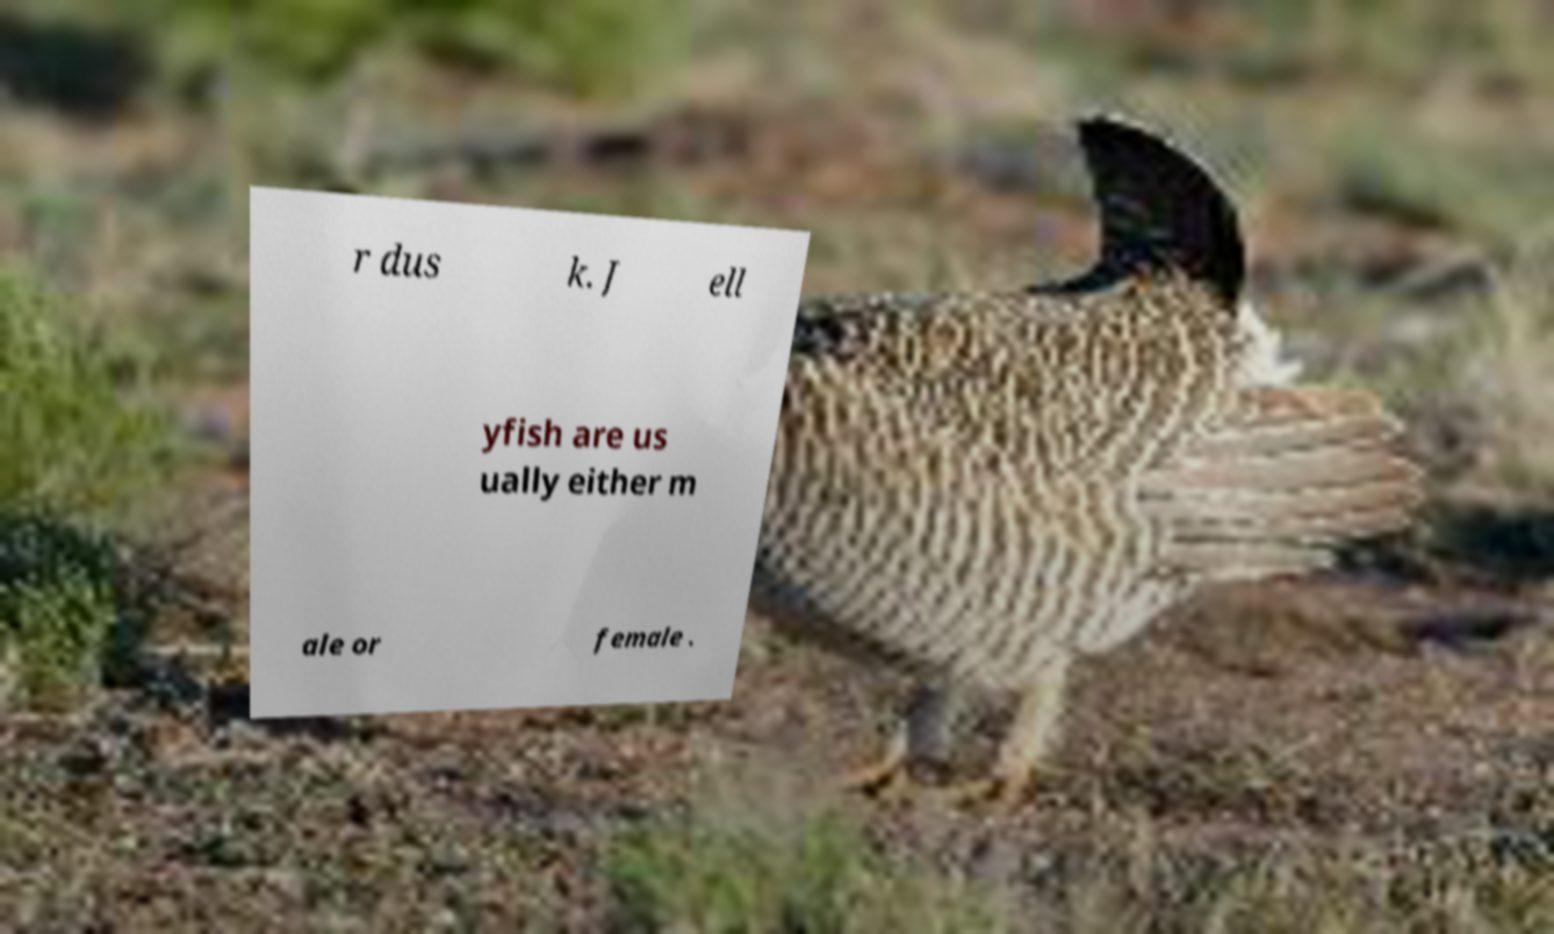Could you assist in decoding the text presented in this image and type it out clearly? r dus k. J ell yfish are us ually either m ale or female . 